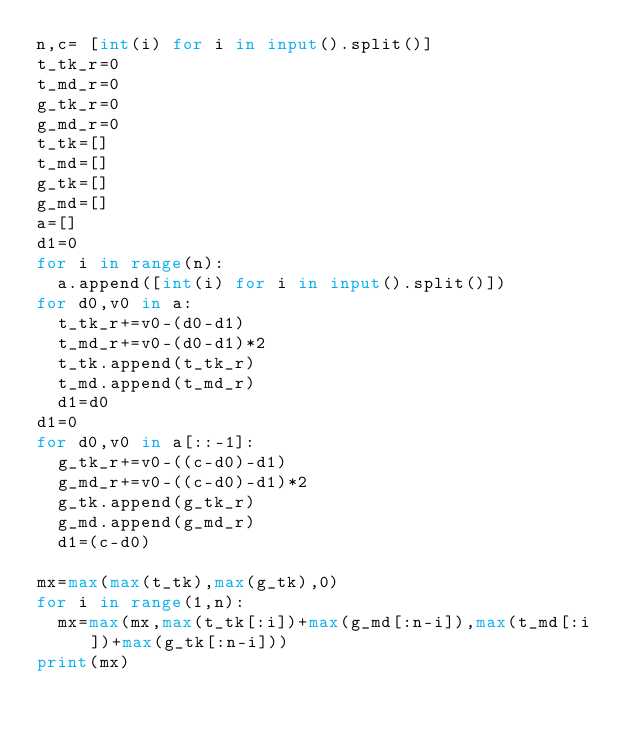Convert code to text. <code><loc_0><loc_0><loc_500><loc_500><_Python_>n,c= [int(i) for i in input().split()]
t_tk_r=0
t_md_r=0
g_tk_r=0
g_md_r=0
t_tk=[]
t_md=[]
g_tk=[]
g_md=[]
a=[]
d1=0
for i in range(n):
  a.append([int(i) for i in input().split()])
for d0,v0 in a:
  t_tk_r+=v0-(d0-d1)
  t_md_r+=v0-(d0-d1)*2
  t_tk.append(t_tk_r)
  t_md.append(t_md_r)
  d1=d0
d1=0  
for d0,v0 in a[::-1]:
  g_tk_r+=v0-((c-d0)-d1)
  g_md_r+=v0-((c-d0)-d1)*2
  g_tk.append(g_tk_r)
  g_md.append(g_md_r)
  d1=(c-d0)
  
mx=max(max(t_tk),max(g_tk),0)
for i in range(1,n):
  mx=max(mx,max(t_tk[:i])+max(g_md[:n-i]),max(t_md[:i])+max(g_tk[:n-i]))
print(mx)</code> 